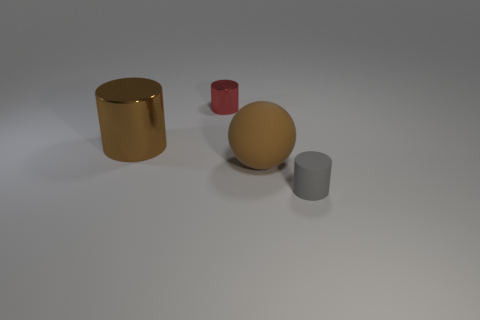Subtract 1 cylinders. How many cylinders are left? 2 Add 2 large brown rubber balls. How many objects exist? 6 Add 1 large brown shiny cylinders. How many large brown shiny cylinders exist? 2 Subtract 0 green cylinders. How many objects are left? 4 Subtract all balls. How many objects are left? 3 Subtract all blue metal objects. Subtract all tiny matte cylinders. How many objects are left? 3 Add 4 small gray matte cylinders. How many small gray matte cylinders are left? 5 